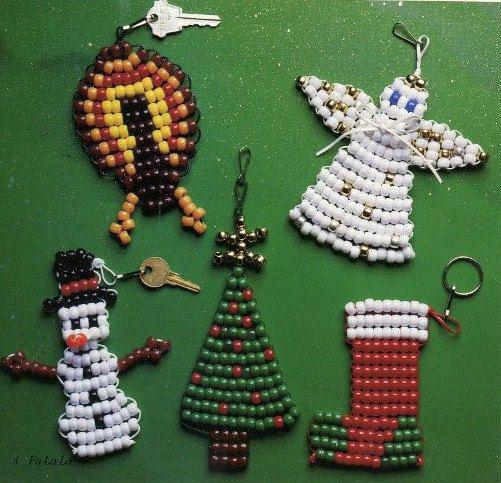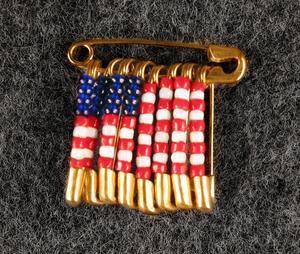The first image is the image on the left, the second image is the image on the right. For the images shown, is this caption "Left image includes an item made of beads, shaped like a Christmas tree with a star on top." true? Answer yes or no. Yes. 